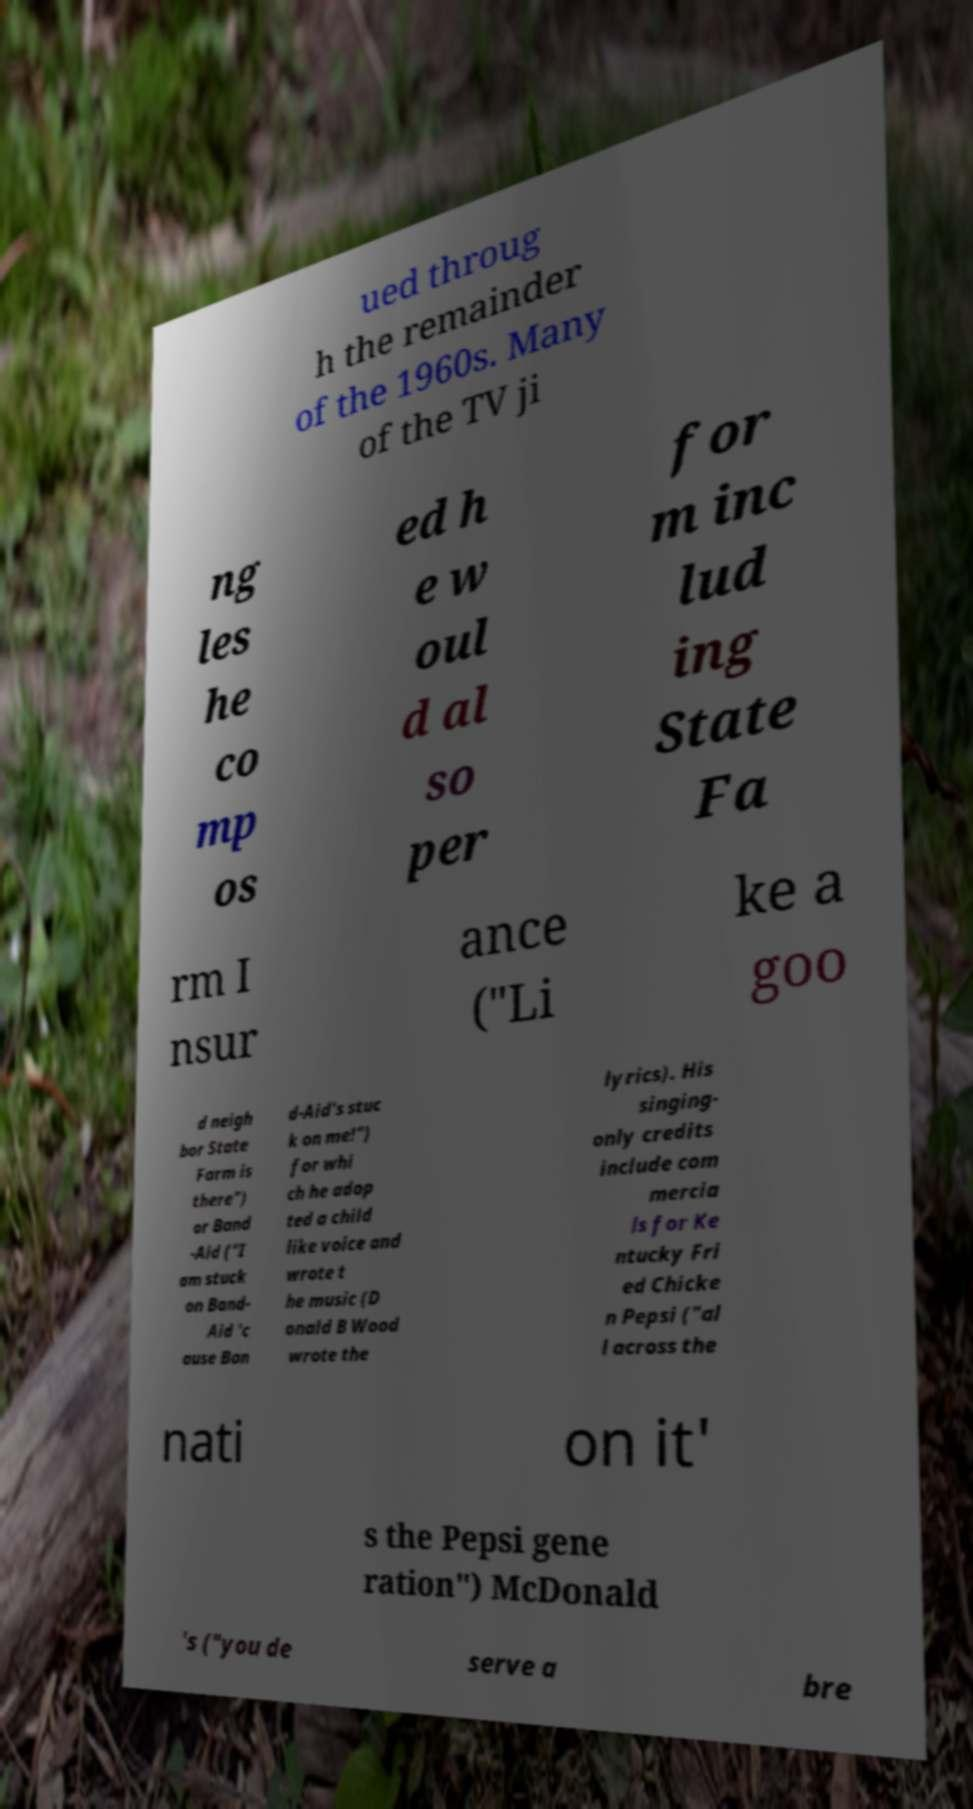I need the written content from this picture converted into text. Can you do that? ued throug h the remainder of the 1960s. Many of the TV ji ng les he co mp os ed h e w oul d al so per for m inc lud ing State Fa rm I nsur ance ("Li ke a goo d neigh bor State Farm is there") or Band -Aid ("I am stuck on Band- Aid 'c ause Ban d-Aid's stuc k on me!") for whi ch he adop ted a child like voice and wrote t he music (D onald B Wood wrote the lyrics). His singing- only credits include com mercia ls for Ke ntucky Fri ed Chicke n Pepsi ("al l across the nati on it' s the Pepsi gene ration") McDonald 's ("you de serve a bre 